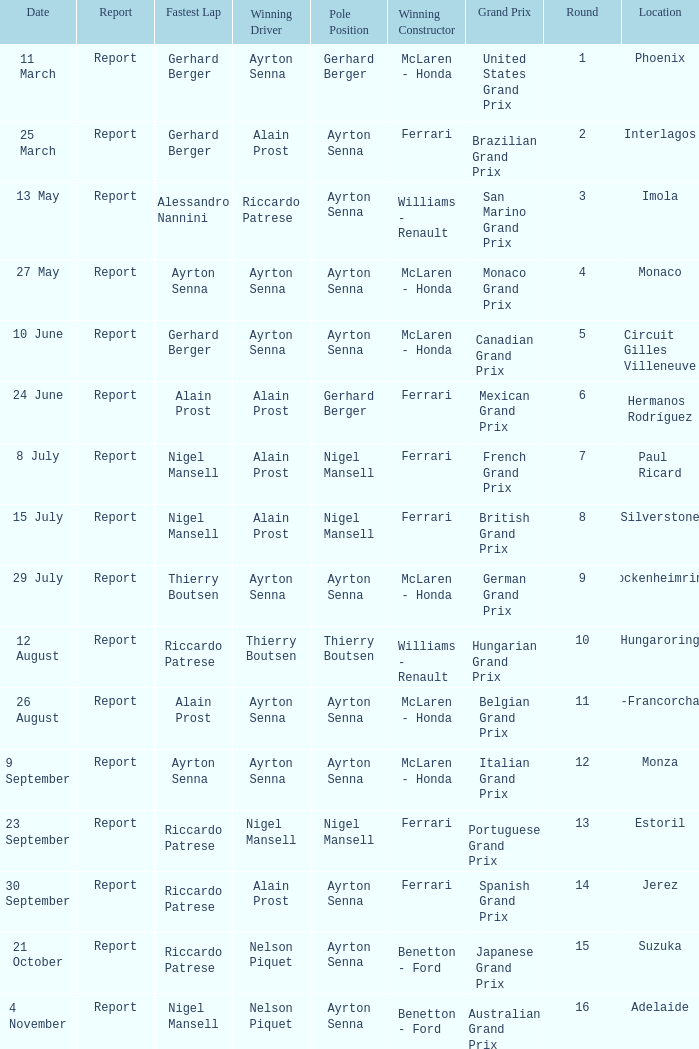What is the date that Ayrton Senna was the drive in Monza? 9 September. 